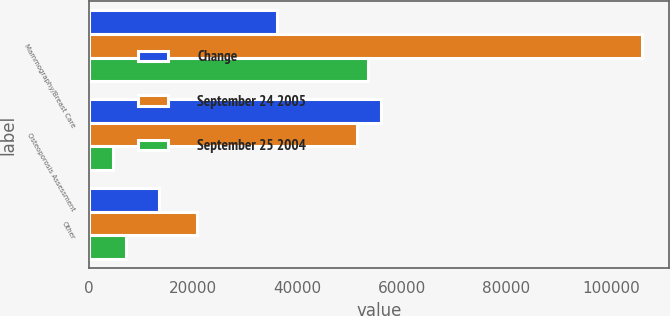<chart> <loc_0><loc_0><loc_500><loc_500><stacked_bar_chart><ecel><fcel>Mammography/Breast Care<fcel>Osteoporosis Assessment<fcel>Other<nl><fcel>Change<fcel>36015<fcel>56065<fcel>13541<nl><fcel>September 24 2005<fcel>105906<fcel>51376<fcel>20654<nl><fcel>September 25 2004<fcel>53563<fcel>4689<fcel>7113<nl></chart> 